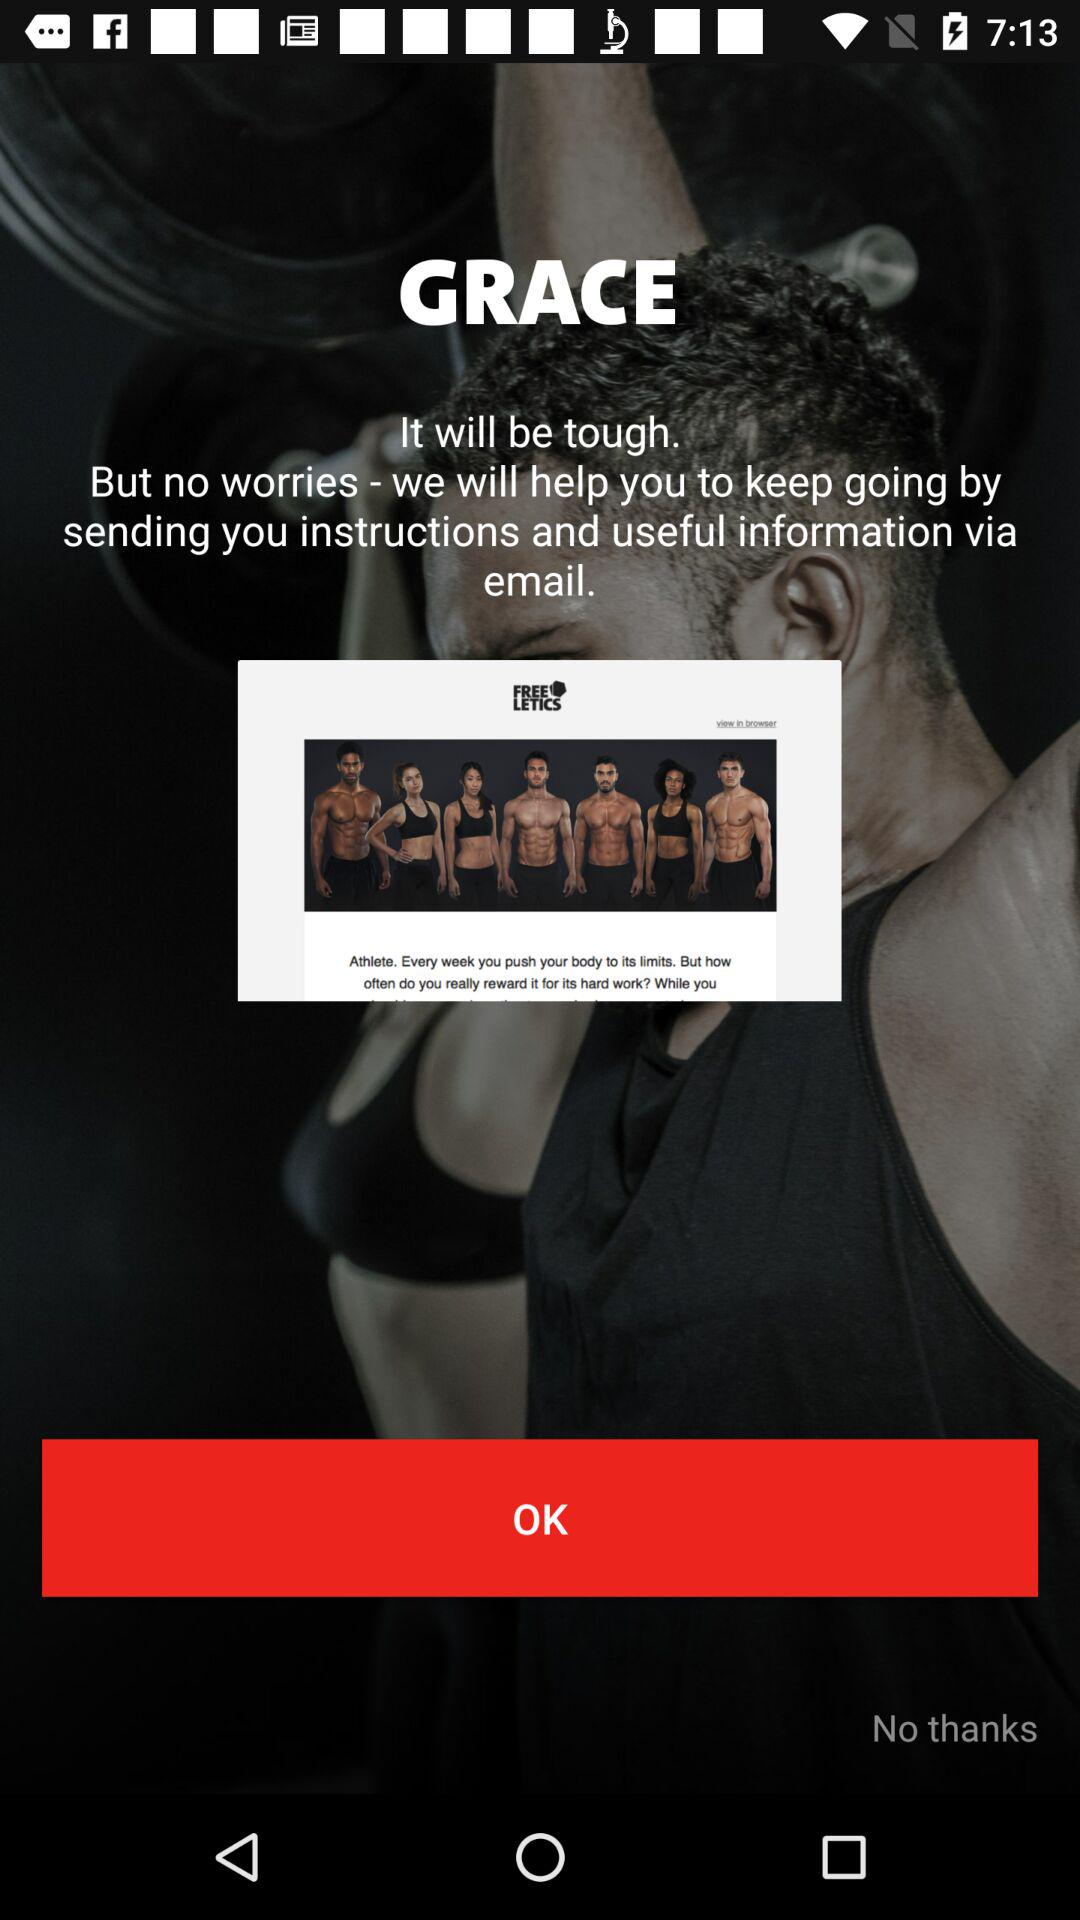Who is this application powered by?
When the provided information is insufficient, respond with <no answer>. <no answer> 